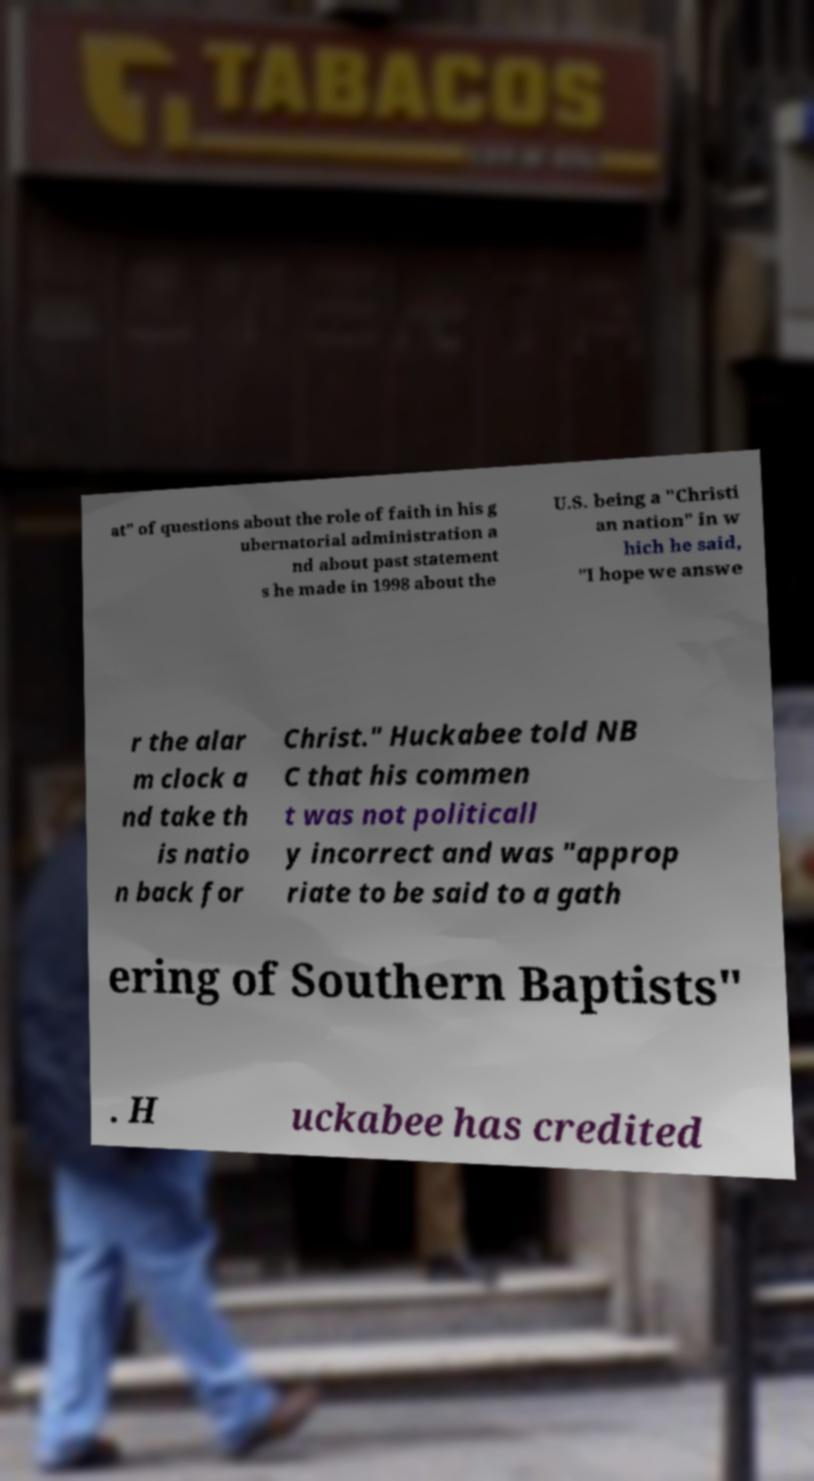Can you accurately transcribe the text from the provided image for me? at" of questions about the role of faith in his g ubernatorial administration a nd about past statement s he made in 1998 about the U.S. being a "Christi an nation" in w hich he said, "I hope we answe r the alar m clock a nd take th is natio n back for Christ." Huckabee told NB C that his commen t was not politicall y incorrect and was "approp riate to be said to a gath ering of Southern Baptists" . H uckabee has credited 